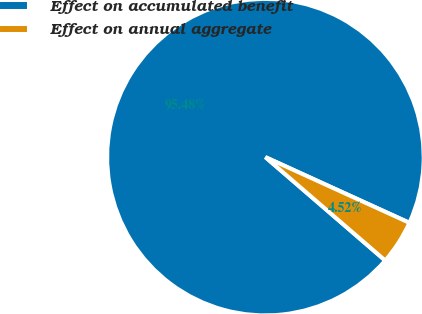Convert chart to OTSL. <chart><loc_0><loc_0><loc_500><loc_500><pie_chart><fcel>Effect on accumulated benefit<fcel>Effect on annual aggregate<nl><fcel>95.48%<fcel>4.52%<nl></chart> 